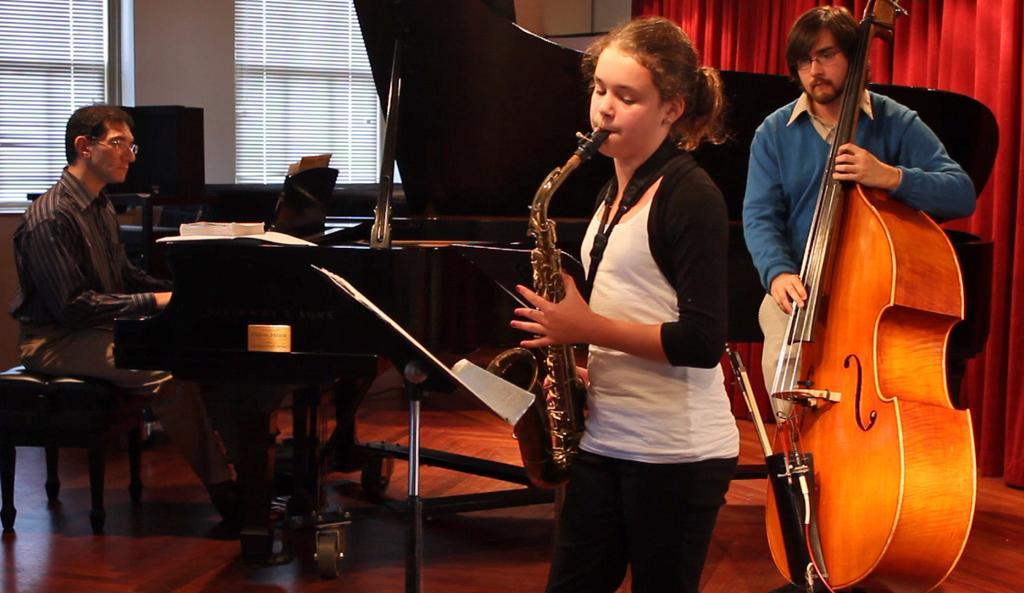Describe this image in one or two sentences. There is a girl playing a french trumpet. She is wearing a white t shirt. Behind her there is a man standing holding a violin in his hands. In Front of the girl there is a stand for holding a paper or book. Beside her there is man playing a piano and there is a book on the piano. In the background, we can observe some windows here. On the right side there is a curtain in the background. 